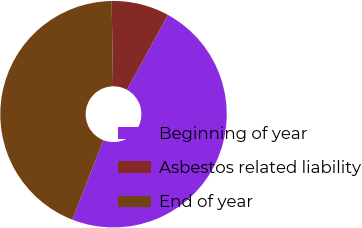Convert chart to OTSL. <chart><loc_0><loc_0><loc_500><loc_500><pie_chart><fcel>Beginning of year<fcel>Asbestos related liability<fcel>End of year<nl><fcel>47.94%<fcel>8.25%<fcel>43.81%<nl></chart> 